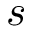Convert formula to latex. <formula><loc_0><loc_0><loc_500><loc_500>s</formula> 